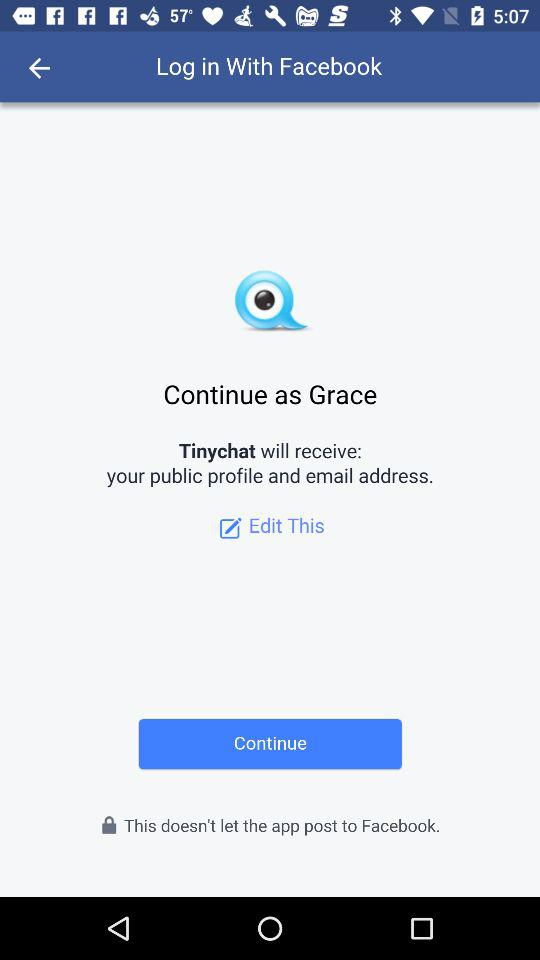How can we login? We can login through Facebook. 